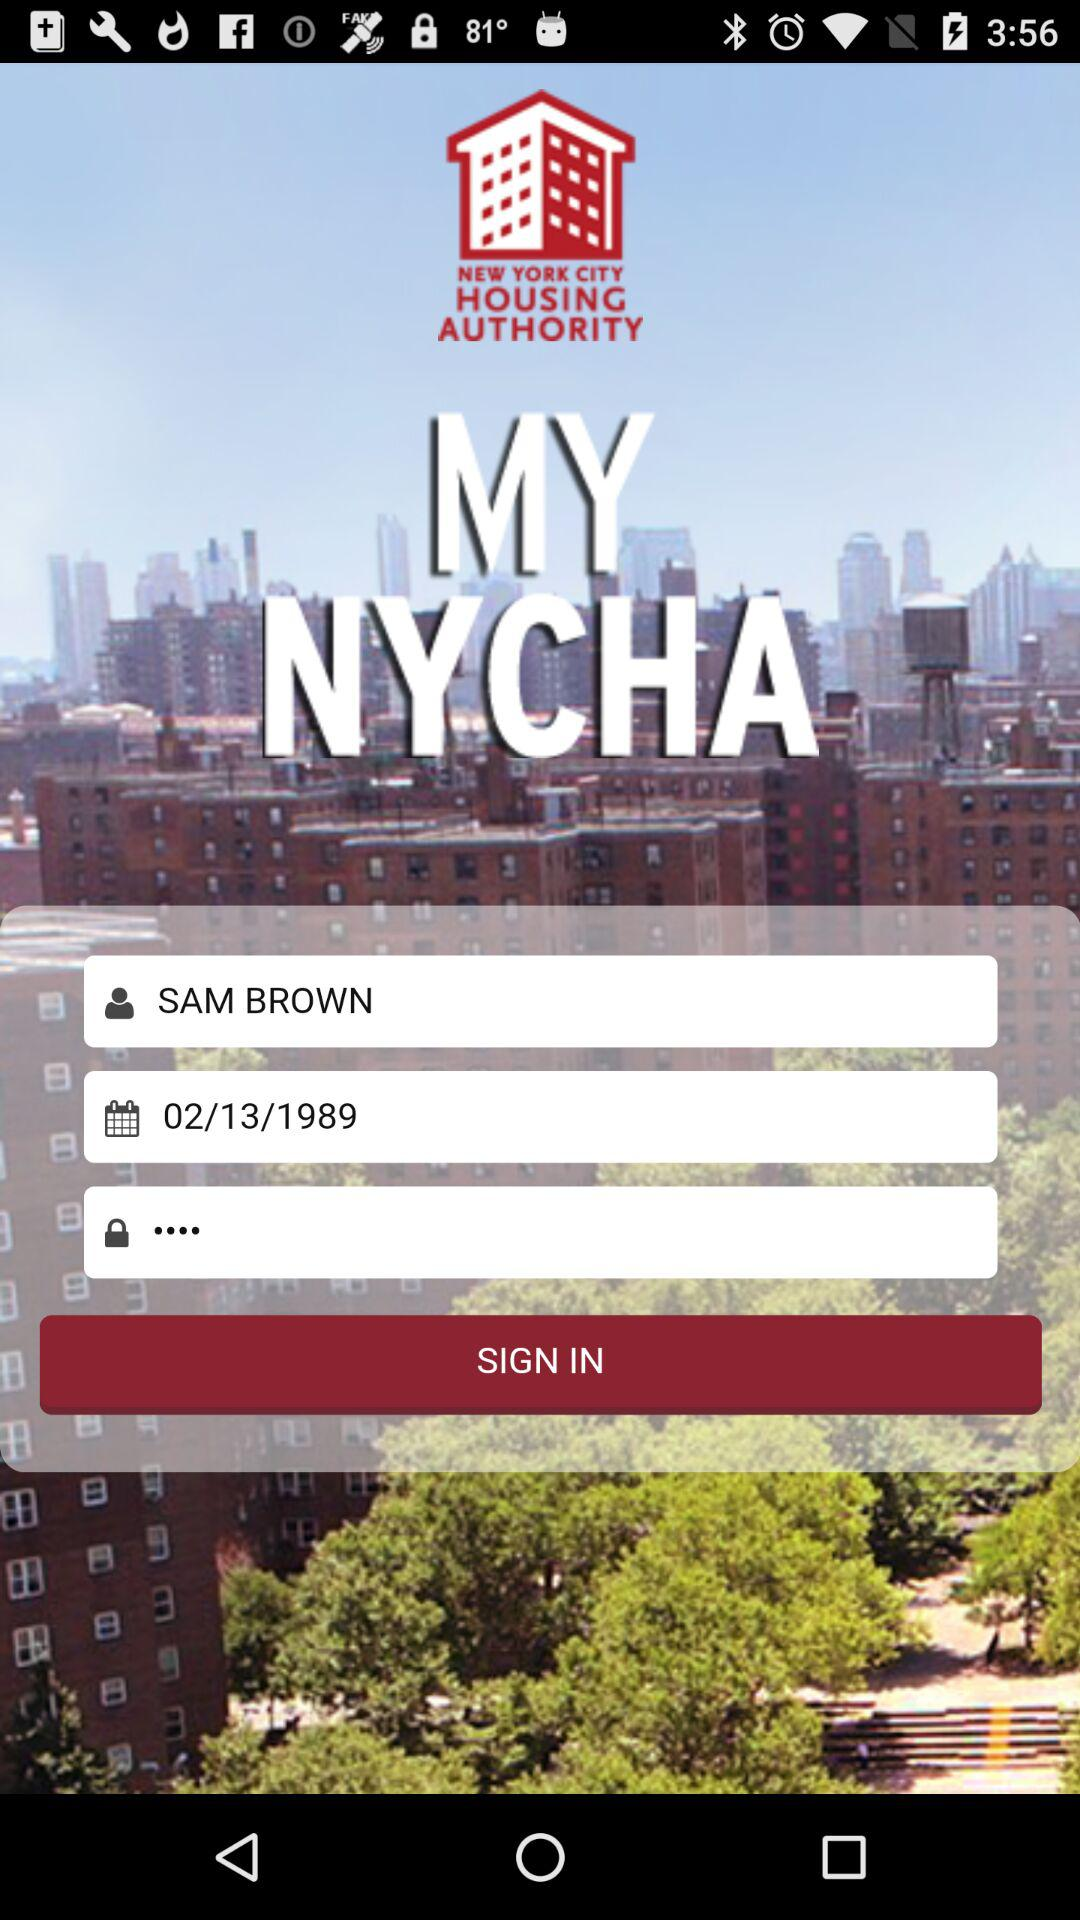What is the date of birth given? The date of birth given is February 13, 1989. 